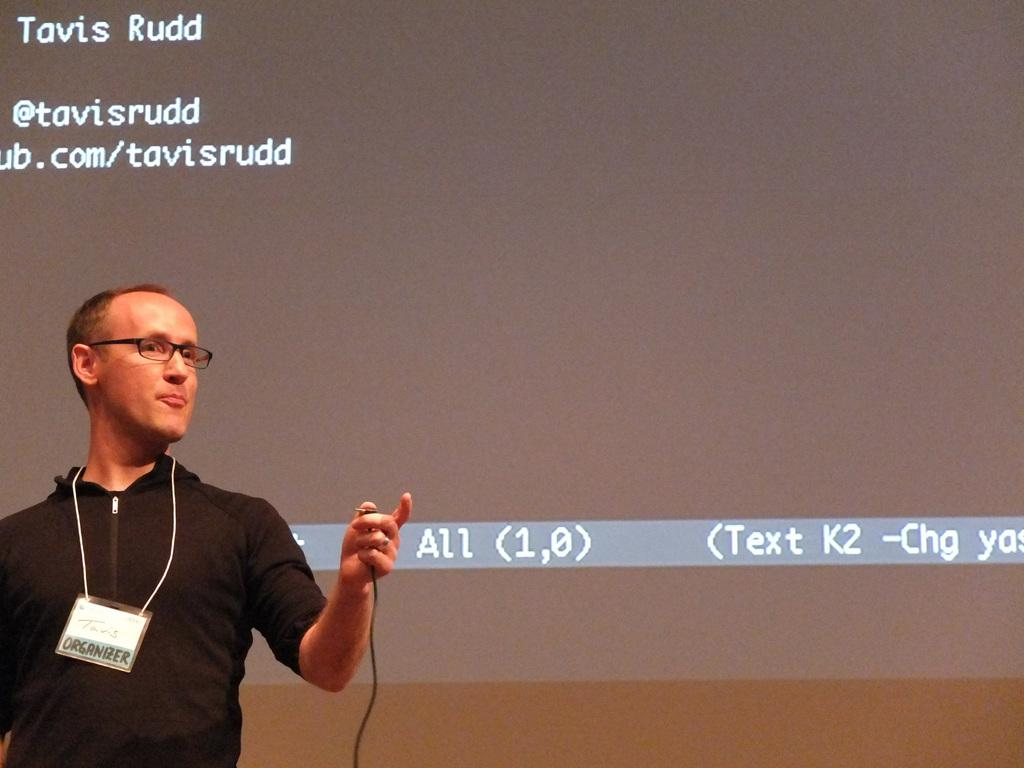Who or what is present in the image? There is a person in the image. What can be observed about the person's appearance? The person is wearing clothes and spectacles. What else can be seen in the image? There is text visible in the background of the image. What type of whip is being used by the queen in the image? There is no queen or whip present in the image; it features a person wearing clothes and spectacles with text visible in the background. 